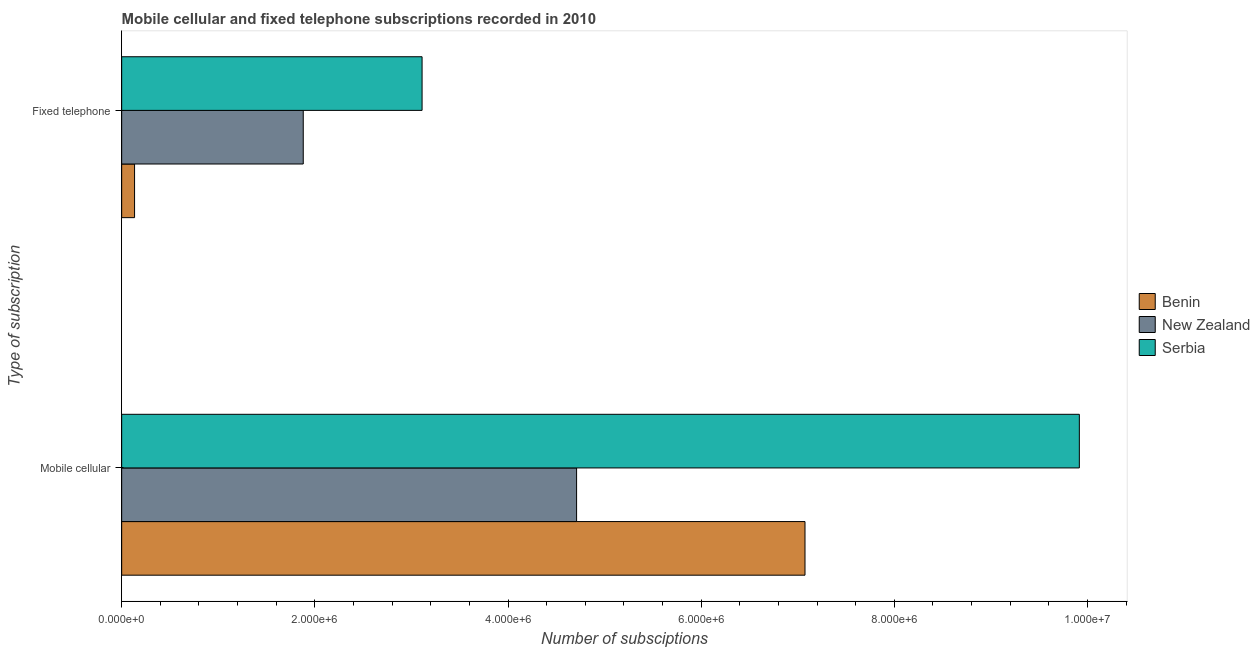How many different coloured bars are there?
Your response must be concise. 3. How many groups of bars are there?
Offer a terse response. 2. How many bars are there on the 2nd tick from the bottom?
Keep it short and to the point. 3. What is the label of the 2nd group of bars from the top?
Your response must be concise. Mobile cellular. What is the number of fixed telephone subscriptions in Benin?
Offer a terse response. 1.33e+05. Across all countries, what is the maximum number of mobile cellular subscriptions?
Your answer should be very brief. 9.92e+06. Across all countries, what is the minimum number of mobile cellular subscriptions?
Make the answer very short. 4.71e+06. In which country was the number of mobile cellular subscriptions maximum?
Offer a terse response. Serbia. In which country was the number of fixed telephone subscriptions minimum?
Your answer should be very brief. Benin. What is the total number of mobile cellular subscriptions in the graph?
Your answer should be compact. 2.17e+07. What is the difference between the number of mobile cellular subscriptions in New Zealand and that in Benin?
Give a very brief answer. -2.36e+06. What is the difference between the number of fixed telephone subscriptions in New Zealand and the number of mobile cellular subscriptions in Benin?
Your answer should be very brief. -5.19e+06. What is the average number of fixed telephone subscriptions per country?
Provide a succinct answer. 1.71e+06. What is the difference between the number of mobile cellular subscriptions and number of fixed telephone subscriptions in Serbia?
Offer a very short reply. 6.81e+06. What is the ratio of the number of fixed telephone subscriptions in Serbia to that in New Zealand?
Keep it short and to the point. 1.65. In how many countries, is the number of mobile cellular subscriptions greater than the average number of mobile cellular subscriptions taken over all countries?
Offer a terse response. 1. What does the 1st bar from the top in Mobile cellular represents?
Your answer should be very brief. Serbia. What does the 3rd bar from the bottom in Fixed telephone represents?
Give a very brief answer. Serbia. How many bars are there?
Ensure brevity in your answer.  6. Are the values on the major ticks of X-axis written in scientific E-notation?
Give a very brief answer. Yes. Does the graph contain any zero values?
Provide a succinct answer. No. Does the graph contain grids?
Make the answer very short. No. How many legend labels are there?
Your answer should be compact. 3. What is the title of the graph?
Offer a terse response. Mobile cellular and fixed telephone subscriptions recorded in 2010. Does "Malaysia" appear as one of the legend labels in the graph?
Provide a succinct answer. No. What is the label or title of the X-axis?
Offer a very short reply. Number of subsciptions. What is the label or title of the Y-axis?
Give a very brief answer. Type of subscription. What is the Number of subsciptions of Benin in Mobile cellular?
Give a very brief answer. 7.07e+06. What is the Number of subsciptions in New Zealand in Mobile cellular?
Ensure brevity in your answer.  4.71e+06. What is the Number of subsciptions of Serbia in Mobile cellular?
Your answer should be very brief. 9.92e+06. What is the Number of subsciptions of Benin in Fixed telephone?
Ensure brevity in your answer.  1.33e+05. What is the Number of subsciptions of New Zealand in Fixed telephone?
Your answer should be very brief. 1.88e+06. What is the Number of subsciptions of Serbia in Fixed telephone?
Provide a succinct answer. 3.11e+06. Across all Type of subscription, what is the maximum Number of subsciptions in Benin?
Offer a very short reply. 7.07e+06. Across all Type of subscription, what is the maximum Number of subsciptions in New Zealand?
Your response must be concise. 4.71e+06. Across all Type of subscription, what is the maximum Number of subsciptions of Serbia?
Keep it short and to the point. 9.92e+06. Across all Type of subscription, what is the minimum Number of subsciptions in Benin?
Make the answer very short. 1.33e+05. Across all Type of subscription, what is the minimum Number of subsciptions of New Zealand?
Keep it short and to the point. 1.88e+06. Across all Type of subscription, what is the minimum Number of subsciptions in Serbia?
Offer a terse response. 3.11e+06. What is the total Number of subsciptions of Benin in the graph?
Ensure brevity in your answer.  7.21e+06. What is the total Number of subsciptions in New Zealand in the graph?
Your answer should be very brief. 6.59e+06. What is the total Number of subsciptions in Serbia in the graph?
Your response must be concise. 1.30e+07. What is the difference between the Number of subsciptions of Benin in Mobile cellular and that in Fixed telephone?
Your answer should be compact. 6.94e+06. What is the difference between the Number of subsciptions in New Zealand in Mobile cellular and that in Fixed telephone?
Give a very brief answer. 2.83e+06. What is the difference between the Number of subsciptions in Serbia in Mobile cellular and that in Fixed telephone?
Provide a succinct answer. 6.81e+06. What is the difference between the Number of subsciptions in Benin in Mobile cellular and the Number of subsciptions in New Zealand in Fixed telephone?
Your response must be concise. 5.19e+06. What is the difference between the Number of subsciptions in Benin in Mobile cellular and the Number of subsciptions in Serbia in Fixed telephone?
Your answer should be compact. 3.96e+06. What is the difference between the Number of subsciptions in New Zealand in Mobile cellular and the Number of subsciptions in Serbia in Fixed telephone?
Your answer should be very brief. 1.60e+06. What is the average Number of subsciptions in Benin per Type of subscription?
Your response must be concise. 3.60e+06. What is the average Number of subsciptions of New Zealand per Type of subscription?
Ensure brevity in your answer.  3.30e+06. What is the average Number of subsciptions in Serbia per Type of subscription?
Offer a very short reply. 6.51e+06. What is the difference between the Number of subsciptions of Benin and Number of subsciptions of New Zealand in Mobile cellular?
Ensure brevity in your answer.  2.36e+06. What is the difference between the Number of subsciptions of Benin and Number of subsciptions of Serbia in Mobile cellular?
Give a very brief answer. -2.84e+06. What is the difference between the Number of subsciptions of New Zealand and Number of subsciptions of Serbia in Mobile cellular?
Provide a short and direct response. -5.21e+06. What is the difference between the Number of subsciptions of Benin and Number of subsciptions of New Zealand in Fixed telephone?
Provide a short and direct response. -1.75e+06. What is the difference between the Number of subsciptions in Benin and Number of subsciptions in Serbia in Fixed telephone?
Offer a terse response. -2.98e+06. What is the difference between the Number of subsciptions of New Zealand and Number of subsciptions of Serbia in Fixed telephone?
Offer a terse response. -1.23e+06. What is the ratio of the Number of subsciptions in Benin in Mobile cellular to that in Fixed telephone?
Your answer should be compact. 53.02. What is the ratio of the Number of subsciptions in New Zealand in Mobile cellular to that in Fixed telephone?
Keep it short and to the point. 2.51. What is the ratio of the Number of subsciptions of Serbia in Mobile cellular to that in Fixed telephone?
Provide a succinct answer. 3.19. What is the difference between the highest and the second highest Number of subsciptions of Benin?
Offer a very short reply. 6.94e+06. What is the difference between the highest and the second highest Number of subsciptions of New Zealand?
Offer a terse response. 2.83e+06. What is the difference between the highest and the second highest Number of subsciptions in Serbia?
Make the answer very short. 6.81e+06. What is the difference between the highest and the lowest Number of subsciptions of Benin?
Provide a short and direct response. 6.94e+06. What is the difference between the highest and the lowest Number of subsciptions in New Zealand?
Provide a short and direct response. 2.83e+06. What is the difference between the highest and the lowest Number of subsciptions in Serbia?
Your answer should be compact. 6.81e+06. 